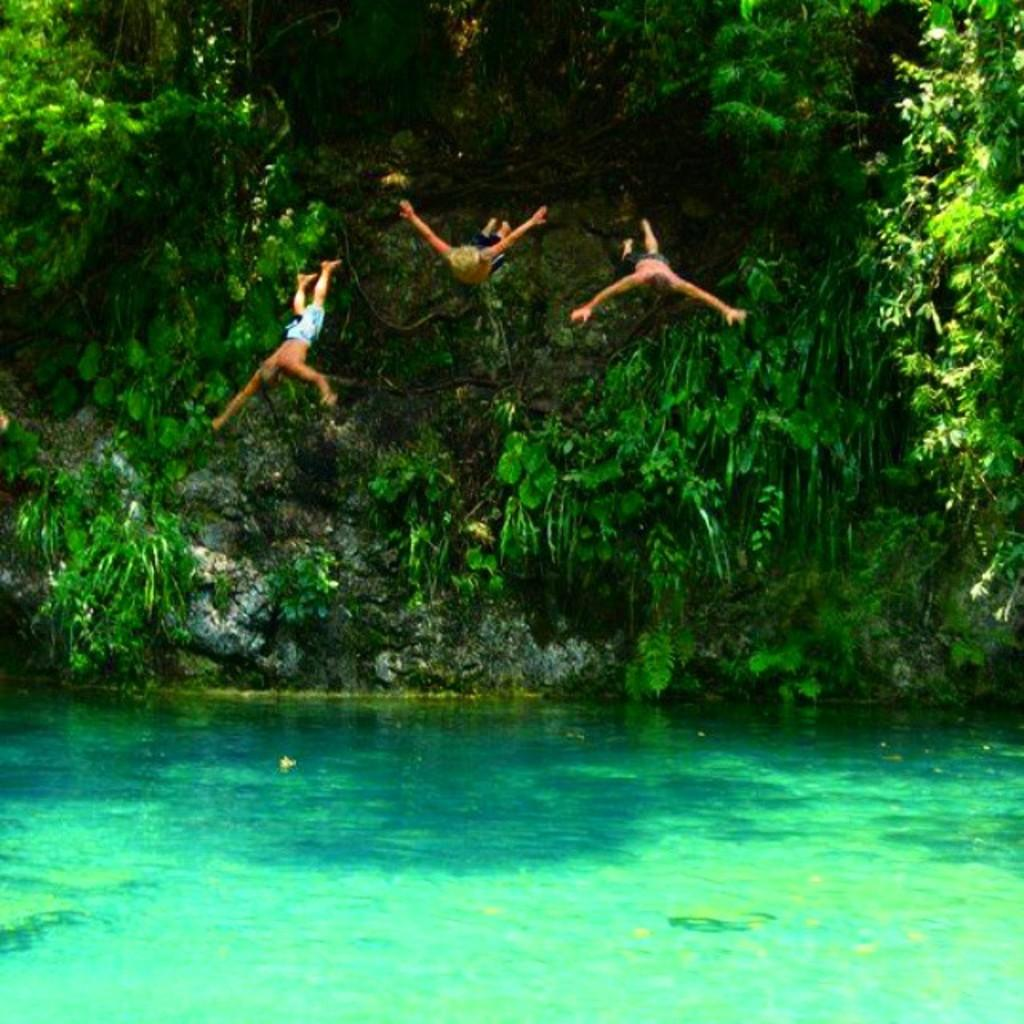Where was the image taken? The image was clicked outside. What can be seen at the bottom of the image? There is water at the bottom of the image. What is located in the middle of the image? There are trees in the middle of the image. What are the three persons in the image doing? The three persons are jumping into the water in the image. How many icicles are hanging from the trees in the image? There are no icicles present in the image; it is taken outside with trees and water, but no icicles are visible. 